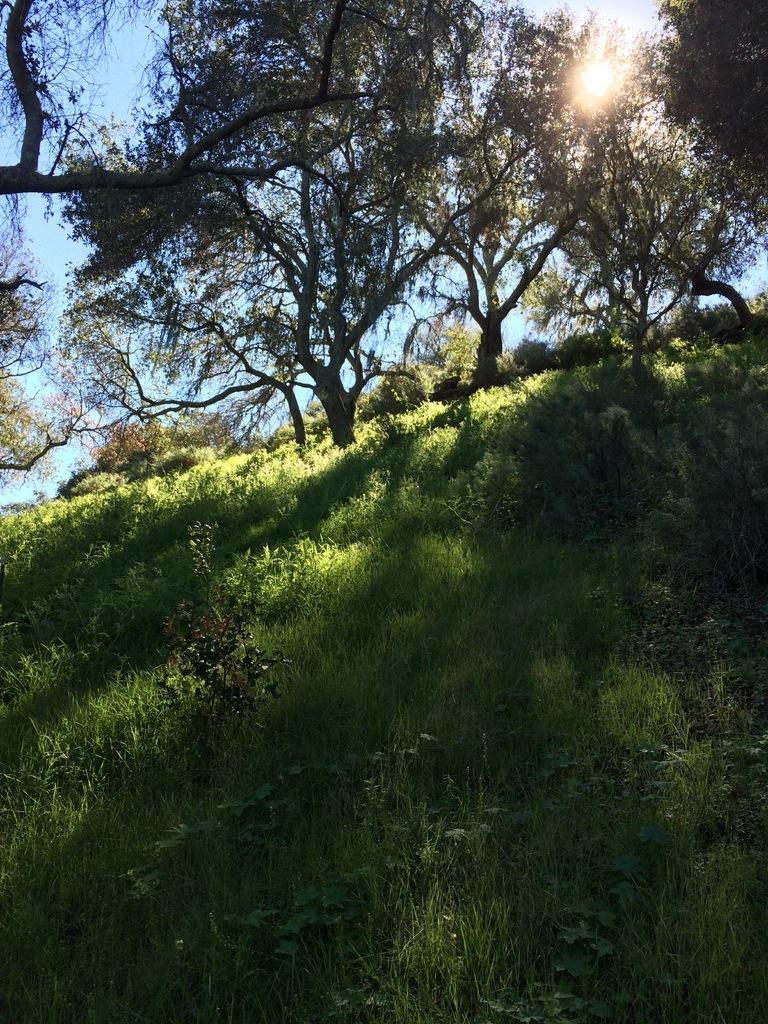What type of vegetation can be seen in the image? There is a group of trees and plants visible in the image. What type of ground cover is present in the image? There is grass visible in the image. What is visible in the sky at the top of the image? The sun is observable in the sky at the top of the image. What is the reason for the argument between the lock and the sun in the image? There is no argument between a lock and the sun in the image, as neither a lock nor an argument is mentioned in the provided facts. 